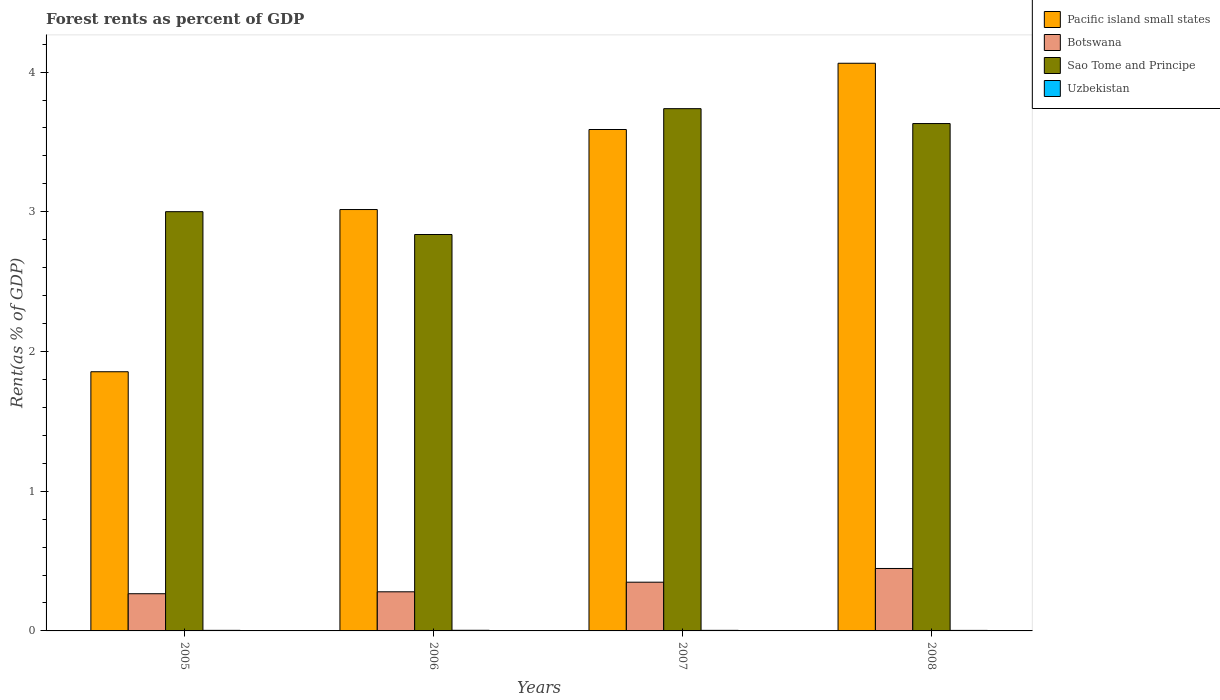How many different coloured bars are there?
Give a very brief answer. 4. Are the number of bars per tick equal to the number of legend labels?
Your answer should be very brief. Yes. Are the number of bars on each tick of the X-axis equal?
Keep it short and to the point. Yes. How many bars are there on the 4th tick from the left?
Provide a short and direct response. 4. In how many cases, is the number of bars for a given year not equal to the number of legend labels?
Provide a succinct answer. 0. What is the forest rent in Botswana in 2005?
Offer a very short reply. 0.27. Across all years, what is the maximum forest rent in Pacific island small states?
Your answer should be very brief. 4.06. Across all years, what is the minimum forest rent in Botswana?
Give a very brief answer. 0.27. In which year was the forest rent in Uzbekistan maximum?
Keep it short and to the point. 2006. What is the total forest rent in Sao Tome and Principe in the graph?
Provide a succinct answer. 13.21. What is the difference between the forest rent in Uzbekistan in 2005 and that in 2006?
Your answer should be very brief. -0. What is the difference between the forest rent in Pacific island small states in 2007 and the forest rent in Botswana in 2008?
Give a very brief answer. 3.14. What is the average forest rent in Sao Tome and Principe per year?
Your response must be concise. 3.3. In the year 2007, what is the difference between the forest rent in Botswana and forest rent in Sao Tome and Principe?
Your answer should be compact. -3.39. In how many years, is the forest rent in Sao Tome and Principe greater than 3 %?
Keep it short and to the point. 3. What is the ratio of the forest rent in Sao Tome and Principe in 2006 to that in 2007?
Your answer should be very brief. 0.76. What is the difference between the highest and the second highest forest rent in Pacific island small states?
Your answer should be very brief. 0.47. What is the difference between the highest and the lowest forest rent in Sao Tome and Principe?
Provide a short and direct response. 0.9. Is it the case that in every year, the sum of the forest rent in Botswana and forest rent in Sao Tome and Principe is greater than the sum of forest rent in Pacific island small states and forest rent in Uzbekistan?
Offer a very short reply. No. What does the 4th bar from the left in 2005 represents?
Your response must be concise. Uzbekistan. What does the 1st bar from the right in 2007 represents?
Your answer should be very brief. Uzbekistan. How many years are there in the graph?
Ensure brevity in your answer.  4. What is the difference between two consecutive major ticks on the Y-axis?
Make the answer very short. 1. Are the values on the major ticks of Y-axis written in scientific E-notation?
Offer a very short reply. No. Does the graph contain any zero values?
Give a very brief answer. No. Does the graph contain grids?
Your response must be concise. No. Where does the legend appear in the graph?
Provide a succinct answer. Top right. How many legend labels are there?
Your answer should be very brief. 4. How are the legend labels stacked?
Your response must be concise. Vertical. What is the title of the graph?
Keep it short and to the point. Forest rents as percent of GDP. Does "Papua New Guinea" appear as one of the legend labels in the graph?
Your response must be concise. No. What is the label or title of the Y-axis?
Ensure brevity in your answer.  Rent(as % of GDP). What is the Rent(as % of GDP) in Pacific island small states in 2005?
Your answer should be very brief. 1.86. What is the Rent(as % of GDP) in Botswana in 2005?
Give a very brief answer. 0.27. What is the Rent(as % of GDP) in Sao Tome and Principe in 2005?
Give a very brief answer. 3. What is the Rent(as % of GDP) in Uzbekistan in 2005?
Keep it short and to the point. 0. What is the Rent(as % of GDP) of Pacific island small states in 2006?
Your answer should be compact. 3.02. What is the Rent(as % of GDP) of Botswana in 2006?
Provide a succinct answer. 0.28. What is the Rent(as % of GDP) of Sao Tome and Principe in 2006?
Your answer should be compact. 2.84. What is the Rent(as % of GDP) in Uzbekistan in 2006?
Give a very brief answer. 0. What is the Rent(as % of GDP) of Pacific island small states in 2007?
Make the answer very short. 3.59. What is the Rent(as % of GDP) in Botswana in 2007?
Your response must be concise. 0.35. What is the Rent(as % of GDP) in Sao Tome and Principe in 2007?
Your response must be concise. 3.74. What is the Rent(as % of GDP) of Uzbekistan in 2007?
Ensure brevity in your answer.  0. What is the Rent(as % of GDP) of Pacific island small states in 2008?
Ensure brevity in your answer.  4.06. What is the Rent(as % of GDP) of Botswana in 2008?
Offer a very short reply. 0.45. What is the Rent(as % of GDP) in Sao Tome and Principe in 2008?
Make the answer very short. 3.63. What is the Rent(as % of GDP) of Uzbekistan in 2008?
Keep it short and to the point. 0. Across all years, what is the maximum Rent(as % of GDP) of Pacific island small states?
Your answer should be compact. 4.06. Across all years, what is the maximum Rent(as % of GDP) in Botswana?
Offer a terse response. 0.45. Across all years, what is the maximum Rent(as % of GDP) in Sao Tome and Principe?
Offer a terse response. 3.74. Across all years, what is the maximum Rent(as % of GDP) of Uzbekistan?
Make the answer very short. 0. Across all years, what is the minimum Rent(as % of GDP) of Pacific island small states?
Your response must be concise. 1.86. Across all years, what is the minimum Rent(as % of GDP) in Botswana?
Your answer should be very brief. 0.27. Across all years, what is the minimum Rent(as % of GDP) of Sao Tome and Principe?
Your answer should be very brief. 2.84. Across all years, what is the minimum Rent(as % of GDP) in Uzbekistan?
Your answer should be compact. 0. What is the total Rent(as % of GDP) of Pacific island small states in the graph?
Offer a very short reply. 12.52. What is the total Rent(as % of GDP) in Botswana in the graph?
Give a very brief answer. 1.34. What is the total Rent(as % of GDP) in Sao Tome and Principe in the graph?
Your answer should be very brief. 13.21. What is the total Rent(as % of GDP) of Uzbekistan in the graph?
Make the answer very short. 0.02. What is the difference between the Rent(as % of GDP) of Pacific island small states in 2005 and that in 2006?
Provide a short and direct response. -1.16. What is the difference between the Rent(as % of GDP) of Botswana in 2005 and that in 2006?
Your answer should be compact. -0.01. What is the difference between the Rent(as % of GDP) in Sao Tome and Principe in 2005 and that in 2006?
Ensure brevity in your answer.  0.16. What is the difference between the Rent(as % of GDP) of Uzbekistan in 2005 and that in 2006?
Offer a very short reply. -0. What is the difference between the Rent(as % of GDP) of Pacific island small states in 2005 and that in 2007?
Your answer should be very brief. -1.73. What is the difference between the Rent(as % of GDP) in Botswana in 2005 and that in 2007?
Your answer should be very brief. -0.08. What is the difference between the Rent(as % of GDP) of Sao Tome and Principe in 2005 and that in 2007?
Offer a terse response. -0.74. What is the difference between the Rent(as % of GDP) of Uzbekistan in 2005 and that in 2007?
Your answer should be very brief. 0. What is the difference between the Rent(as % of GDP) of Pacific island small states in 2005 and that in 2008?
Offer a very short reply. -2.21. What is the difference between the Rent(as % of GDP) in Botswana in 2005 and that in 2008?
Your response must be concise. -0.18. What is the difference between the Rent(as % of GDP) in Sao Tome and Principe in 2005 and that in 2008?
Keep it short and to the point. -0.63. What is the difference between the Rent(as % of GDP) of Uzbekistan in 2005 and that in 2008?
Provide a short and direct response. 0. What is the difference between the Rent(as % of GDP) in Pacific island small states in 2006 and that in 2007?
Keep it short and to the point. -0.57. What is the difference between the Rent(as % of GDP) in Botswana in 2006 and that in 2007?
Provide a succinct answer. -0.07. What is the difference between the Rent(as % of GDP) of Sao Tome and Principe in 2006 and that in 2007?
Your answer should be very brief. -0.9. What is the difference between the Rent(as % of GDP) in Uzbekistan in 2006 and that in 2007?
Make the answer very short. 0. What is the difference between the Rent(as % of GDP) of Pacific island small states in 2006 and that in 2008?
Offer a terse response. -1.05. What is the difference between the Rent(as % of GDP) of Botswana in 2006 and that in 2008?
Ensure brevity in your answer.  -0.17. What is the difference between the Rent(as % of GDP) of Sao Tome and Principe in 2006 and that in 2008?
Provide a succinct answer. -0.79. What is the difference between the Rent(as % of GDP) in Uzbekistan in 2006 and that in 2008?
Your answer should be very brief. 0. What is the difference between the Rent(as % of GDP) in Pacific island small states in 2007 and that in 2008?
Give a very brief answer. -0.47. What is the difference between the Rent(as % of GDP) in Botswana in 2007 and that in 2008?
Ensure brevity in your answer.  -0.1. What is the difference between the Rent(as % of GDP) of Sao Tome and Principe in 2007 and that in 2008?
Your answer should be very brief. 0.11. What is the difference between the Rent(as % of GDP) of Uzbekistan in 2007 and that in 2008?
Make the answer very short. 0. What is the difference between the Rent(as % of GDP) of Pacific island small states in 2005 and the Rent(as % of GDP) of Botswana in 2006?
Give a very brief answer. 1.58. What is the difference between the Rent(as % of GDP) in Pacific island small states in 2005 and the Rent(as % of GDP) in Sao Tome and Principe in 2006?
Provide a succinct answer. -0.98. What is the difference between the Rent(as % of GDP) of Pacific island small states in 2005 and the Rent(as % of GDP) of Uzbekistan in 2006?
Offer a terse response. 1.85. What is the difference between the Rent(as % of GDP) of Botswana in 2005 and the Rent(as % of GDP) of Sao Tome and Principe in 2006?
Your response must be concise. -2.57. What is the difference between the Rent(as % of GDP) of Botswana in 2005 and the Rent(as % of GDP) of Uzbekistan in 2006?
Ensure brevity in your answer.  0.26. What is the difference between the Rent(as % of GDP) in Sao Tome and Principe in 2005 and the Rent(as % of GDP) in Uzbekistan in 2006?
Make the answer very short. 3. What is the difference between the Rent(as % of GDP) of Pacific island small states in 2005 and the Rent(as % of GDP) of Botswana in 2007?
Keep it short and to the point. 1.51. What is the difference between the Rent(as % of GDP) of Pacific island small states in 2005 and the Rent(as % of GDP) of Sao Tome and Principe in 2007?
Provide a short and direct response. -1.88. What is the difference between the Rent(as % of GDP) in Pacific island small states in 2005 and the Rent(as % of GDP) in Uzbekistan in 2007?
Your response must be concise. 1.85. What is the difference between the Rent(as % of GDP) in Botswana in 2005 and the Rent(as % of GDP) in Sao Tome and Principe in 2007?
Keep it short and to the point. -3.47. What is the difference between the Rent(as % of GDP) of Botswana in 2005 and the Rent(as % of GDP) of Uzbekistan in 2007?
Make the answer very short. 0.26. What is the difference between the Rent(as % of GDP) of Sao Tome and Principe in 2005 and the Rent(as % of GDP) of Uzbekistan in 2007?
Your answer should be very brief. 3. What is the difference between the Rent(as % of GDP) in Pacific island small states in 2005 and the Rent(as % of GDP) in Botswana in 2008?
Your response must be concise. 1.41. What is the difference between the Rent(as % of GDP) in Pacific island small states in 2005 and the Rent(as % of GDP) in Sao Tome and Principe in 2008?
Offer a very short reply. -1.78. What is the difference between the Rent(as % of GDP) in Pacific island small states in 2005 and the Rent(as % of GDP) in Uzbekistan in 2008?
Provide a succinct answer. 1.85. What is the difference between the Rent(as % of GDP) of Botswana in 2005 and the Rent(as % of GDP) of Sao Tome and Principe in 2008?
Provide a succinct answer. -3.37. What is the difference between the Rent(as % of GDP) of Botswana in 2005 and the Rent(as % of GDP) of Uzbekistan in 2008?
Your response must be concise. 0.26. What is the difference between the Rent(as % of GDP) in Sao Tome and Principe in 2005 and the Rent(as % of GDP) in Uzbekistan in 2008?
Your response must be concise. 3. What is the difference between the Rent(as % of GDP) of Pacific island small states in 2006 and the Rent(as % of GDP) of Botswana in 2007?
Provide a short and direct response. 2.67. What is the difference between the Rent(as % of GDP) of Pacific island small states in 2006 and the Rent(as % of GDP) of Sao Tome and Principe in 2007?
Offer a terse response. -0.72. What is the difference between the Rent(as % of GDP) in Pacific island small states in 2006 and the Rent(as % of GDP) in Uzbekistan in 2007?
Offer a very short reply. 3.01. What is the difference between the Rent(as % of GDP) in Botswana in 2006 and the Rent(as % of GDP) in Sao Tome and Principe in 2007?
Your answer should be very brief. -3.46. What is the difference between the Rent(as % of GDP) in Botswana in 2006 and the Rent(as % of GDP) in Uzbekistan in 2007?
Ensure brevity in your answer.  0.28. What is the difference between the Rent(as % of GDP) of Sao Tome and Principe in 2006 and the Rent(as % of GDP) of Uzbekistan in 2007?
Offer a very short reply. 2.83. What is the difference between the Rent(as % of GDP) in Pacific island small states in 2006 and the Rent(as % of GDP) in Botswana in 2008?
Your answer should be very brief. 2.57. What is the difference between the Rent(as % of GDP) in Pacific island small states in 2006 and the Rent(as % of GDP) in Sao Tome and Principe in 2008?
Keep it short and to the point. -0.62. What is the difference between the Rent(as % of GDP) in Pacific island small states in 2006 and the Rent(as % of GDP) in Uzbekistan in 2008?
Offer a very short reply. 3.01. What is the difference between the Rent(as % of GDP) of Botswana in 2006 and the Rent(as % of GDP) of Sao Tome and Principe in 2008?
Give a very brief answer. -3.35. What is the difference between the Rent(as % of GDP) of Botswana in 2006 and the Rent(as % of GDP) of Uzbekistan in 2008?
Your answer should be compact. 0.28. What is the difference between the Rent(as % of GDP) of Sao Tome and Principe in 2006 and the Rent(as % of GDP) of Uzbekistan in 2008?
Keep it short and to the point. 2.83. What is the difference between the Rent(as % of GDP) of Pacific island small states in 2007 and the Rent(as % of GDP) of Botswana in 2008?
Give a very brief answer. 3.14. What is the difference between the Rent(as % of GDP) of Pacific island small states in 2007 and the Rent(as % of GDP) of Sao Tome and Principe in 2008?
Make the answer very short. -0.04. What is the difference between the Rent(as % of GDP) in Pacific island small states in 2007 and the Rent(as % of GDP) in Uzbekistan in 2008?
Offer a terse response. 3.59. What is the difference between the Rent(as % of GDP) of Botswana in 2007 and the Rent(as % of GDP) of Sao Tome and Principe in 2008?
Keep it short and to the point. -3.28. What is the difference between the Rent(as % of GDP) of Botswana in 2007 and the Rent(as % of GDP) of Uzbekistan in 2008?
Ensure brevity in your answer.  0.34. What is the difference between the Rent(as % of GDP) of Sao Tome and Principe in 2007 and the Rent(as % of GDP) of Uzbekistan in 2008?
Your answer should be very brief. 3.73. What is the average Rent(as % of GDP) of Pacific island small states per year?
Provide a succinct answer. 3.13. What is the average Rent(as % of GDP) of Botswana per year?
Make the answer very short. 0.34. What is the average Rent(as % of GDP) in Sao Tome and Principe per year?
Your answer should be very brief. 3.3. What is the average Rent(as % of GDP) in Uzbekistan per year?
Offer a very short reply. 0. In the year 2005, what is the difference between the Rent(as % of GDP) of Pacific island small states and Rent(as % of GDP) of Botswana?
Offer a terse response. 1.59. In the year 2005, what is the difference between the Rent(as % of GDP) in Pacific island small states and Rent(as % of GDP) in Sao Tome and Principe?
Provide a short and direct response. -1.15. In the year 2005, what is the difference between the Rent(as % of GDP) in Pacific island small states and Rent(as % of GDP) in Uzbekistan?
Give a very brief answer. 1.85. In the year 2005, what is the difference between the Rent(as % of GDP) of Botswana and Rent(as % of GDP) of Sao Tome and Principe?
Offer a very short reply. -2.73. In the year 2005, what is the difference between the Rent(as % of GDP) in Botswana and Rent(as % of GDP) in Uzbekistan?
Make the answer very short. 0.26. In the year 2005, what is the difference between the Rent(as % of GDP) of Sao Tome and Principe and Rent(as % of GDP) of Uzbekistan?
Ensure brevity in your answer.  3. In the year 2006, what is the difference between the Rent(as % of GDP) in Pacific island small states and Rent(as % of GDP) in Botswana?
Provide a succinct answer. 2.74. In the year 2006, what is the difference between the Rent(as % of GDP) in Pacific island small states and Rent(as % of GDP) in Sao Tome and Principe?
Offer a terse response. 0.18. In the year 2006, what is the difference between the Rent(as % of GDP) in Pacific island small states and Rent(as % of GDP) in Uzbekistan?
Make the answer very short. 3.01. In the year 2006, what is the difference between the Rent(as % of GDP) of Botswana and Rent(as % of GDP) of Sao Tome and Principe?
Your answer should be compact. -2.56. In the year 2006, what is the difference between the Rent(as % of GDP) of Botswana and Rent(as % of GDP) of Uzbekistan?
Give a very brief answer. 0.28. In the year 2006, what is the difference between the Rent(as % of GDP) in Sao Tome and Principe and Rent(as % of GDP) in Uzbekistan?
Offer a very short reply. 2.83. In the year 2007, what is the difference between the Rent(as % of GDP) of Pacific island small states and Rent(as % of GDP) of Botswana?
Your response must be concise. 3.24. In the year 2007, what is the difference between the Rent(as % of GDP) in Pacific island small states and Rent(as % of GDP) in Sao Tome and Principe?
Provide a short and direct response. -0.15. In the year 2007, what is the difference between the Rent(as % of GDP) of Pacific island small states and Rent(as % of GDP) of Uzbekistan?
Provide a short and direct response. 3.58. In the year 2007, what is the difference between the Rent(as % of GDP) of Botswana and Rent(as % of GDP) of Sao Tome and Principe?
Provide a short and direct response. -3.39. In the year 2007, what is the difference between the Rent(as % of GDP) of Botswana and Rent(as % of GDP) of Uzbekistan?
Your response must be concise. 0.34. In the year 2007, what is the difference between the Rent(as % of GDP) in Sao Tome and Principe and Rent(as % of GDP) in Uzbekistan?
Ensure brevity in your answer.  3.73. In the year 2008, what is the difference between the Rent(as % of GDP) of Pacific island small states and Rent(as % of GDP) of Botswana?
Provide a succinct answer. 3.62. In the year 2008, what is the difference between the Rent(as % of GDP) of Pacific island small states and Rent(as % of GDP) of Sao Tome and Principe?
Provide a succinct answer. 0.43. In the year 2008, what is the difference between the Rent(as % of GDP) in Pacific island small states and Rent(as % of GDP) in Uzbekistan?
Provide a short and direct response. 4.06. In the year 2008, what is the difference between the Rent(as % of GDP) of Botswana and Rent(as % of GDP) of Sao Tome and Principe?
Ensure brevity in your answer.  -3.18. In the year 2008, what is the difference between the Rent(as % of GDP) of Botswana and Rent(as % of GDP) of Uzbekistan?
Provide a short and direct response. 0.44. In the year 2008, what is the difference between the Rent(as % of GDP) of Sao Tome and Principe and Rent(as % of GDP) of Uzbekistan?
Provide a succinct answer. 3.63. What is the ratio of the Rent(as % of GDP) of Pacific island small states in 2005 to that in 2006?
Ensure brevity in your answer.  0.62. What is the ratio of the Rent(as % of GDP) in Botswana in 2005 to that in 2006?
Give a very brief answer. 0.95. What is the ratio of the Rent(as % of GDP) in Sao Tome and Principe in 2005 to that in 2006?
Ensure brevity in your answer.  1.06. What is the ratio of the Rent(as % of GDP) of Uzbekistan in 2005 to that in 2006?
Offer a terse response. 0.91. What is the ratio of the Rent(as % of GDP) of Pacific island small states in 2005 to that in 2007?
Keep it short and to the point. 0.52. What is the ratio of the Rent(as % of GDP) of Botswana in 2005 to that in 2007?
Make the answer very short. 0.76. What is the ratio of the Rent(as % of GDP) in Sao Tome and Principe in 2005 to that in 2007?
Your response must be concise. 0.8. What is the ratio of the Rent(as % of GDP) in Uzbekistan in 2005 to that in 2007?
Provide a succinct answer. 1.02. What is the ratio of the Rent(as % of GDP) of Pacific island small states in 2005 to that in 2008?
Your answer should be very brief. 0.46. What is the ratio of the Rent(as % of GDP) of Botswana in 2005 to that in 2008?
Provide a short and direct response. 0.6. What is the ratio of the Rent(as % of GDP) of Sao Tome and Principe in 2005 to that in 2008?
Give a very brief answer. 0.83. What is the ratio of the Rent(as % of GDP) in Uzbekistan in 2005 to that in 2008?
Provide a short and direct response. 1.09. What is the ratio of the Rent(as % of GDP) of Pacific island small states in 2006 to that in 2007?
Provide a short and direct response. 0.84. What is the ratio of the Rent(as % of GDP) of Botswana in 2006 to that in 2007?
Provide a succinct answer. 0.8. What is the ratio of the Rent(as % of GDP) of Sao Tome and Principe in 2006 to that in 2007?
Your answer should be compact. 0.76. What is the ratio of the Rent(as % of GDP) in Uzbekistan in 2006 to that in 2007?
Your answer should be compact. 1.12. What is the ratio of the Rent(as % of GDP) in Pacific island small states in 2006 to that in 2008?
Provide a short and direct response. 0.74. What is the ratio of the Rent(as % of GDP) in Botswana in 2006 to that in 2008?
Give a very brief answer. 0.63. What is the ratio of the Rent(as % of GDP) in Sao Tome and Principe in 2006 to that in 2008?
Ensure brevity in your answer.  0.78. What is the ratio of the Rent(as % of GDP) in Uzbekistan in 2006 to that in 2008?
Offer a terse response. 1.19. What is the ratio of the Rent(as % of GDP) of Pacific island small states in 2007 to that in 2008?
Ensure brevity in your answer.  0.88. What is the ratio of the Rent(as % of GDP) in Botswana in 2007 to that in 2008?
Provide a succinct answer. 0.78. What is the ratio of the Rent(as % of GDP) in Sao Tome and Principe in 2007 to that in 2008?
Ensure brevity in your answer.  1.03. What is the ratio of the Rent(as % of GDP) in Uzbekistan in 2007 to that in 2008?
Keep it short and to the point. 1.07. What is the difference between the highest and the second highest Rent(as % of GDP) in Pacific island small states?
Ensure brevity in your answer.  0.47. What is the difference between the highest and the second highest Rent(as % of GDP) of Botswana?
Offer a terse response. 0.1. What is the difference between the highest and the second highest Rent(as % of GDP) of Sao Tome and Principe?
Give a very brief answer. 0.11. What is the difference between the highest and the second highest Rent(as % of GDP) in Uzbekistan?
Your response must be concise. 0. What is the difference between the highest and the lowest Rent(as % of GDP) in Pacific island small states?
Your response must be concise. 2.21. What is the difference between the highest and the lowest Rent(as % of GDP) in Botswana?
Give a very brief answer. 0.18. What is the difference between the highest and the lowest Rent(as % of GDP) in Sao Tome and Principe?
Offer a very short reply. 0.9. What is the difference between the highest and the lowest Rent(as % of GDP) of Uzbekistan?
Offer a terse response. 0. 